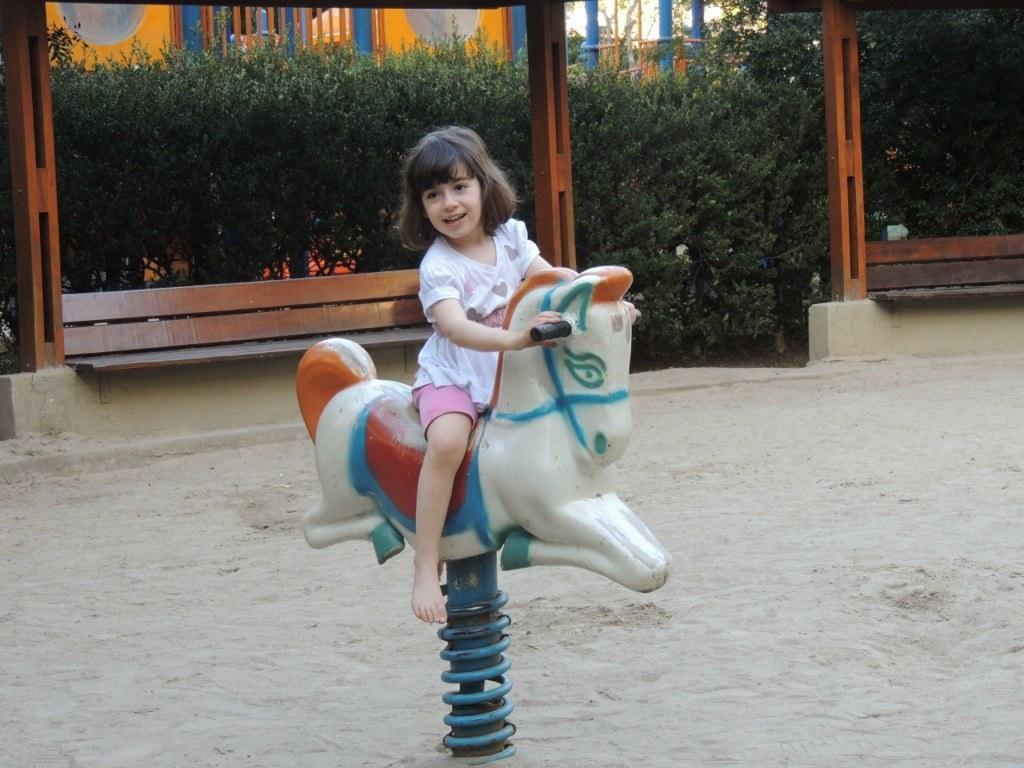In one or two sentences, can you explain what this image depicts? In this image there is a girl riding a toy horse in a playground, in the background there are plants and poles. 